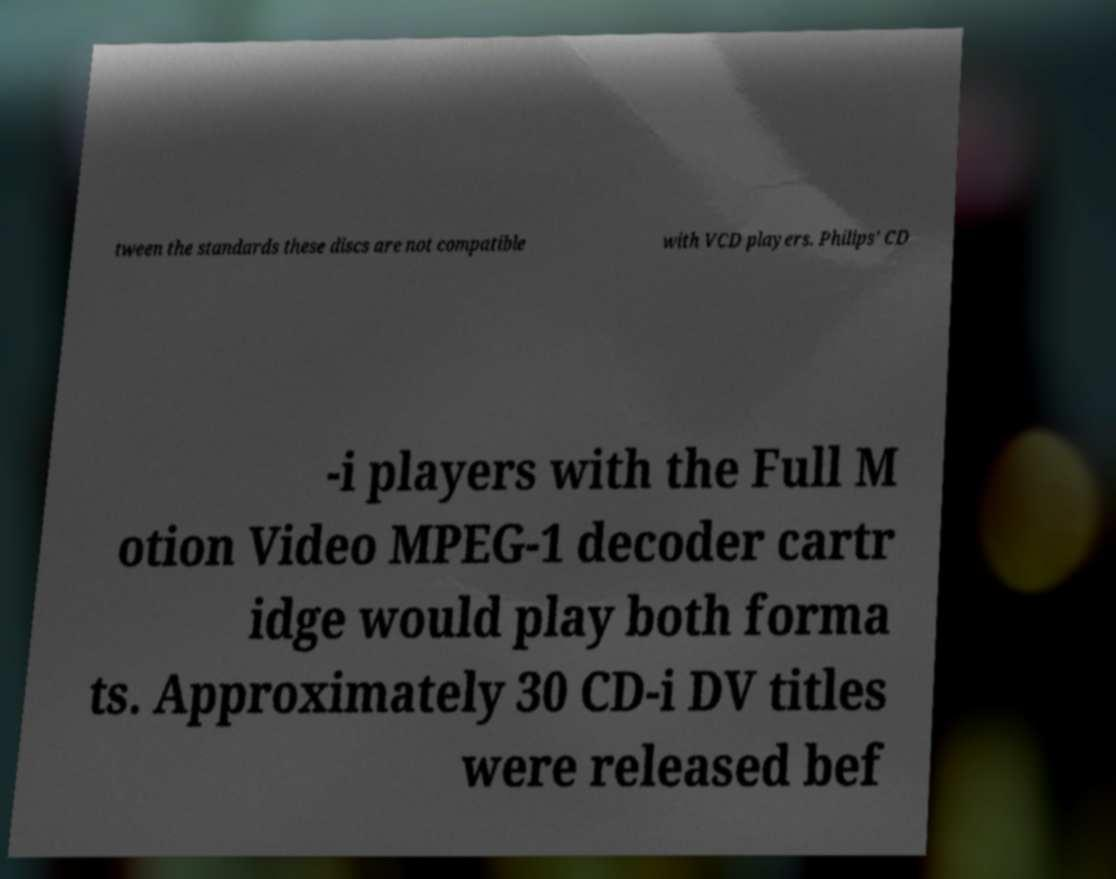Could you extract and type out the text from this image? tween the standards these discs are not compatible with VCD players. Philips' CD -i players with the Full M otion Video MPEG-1 decoder cartr idge would play both forma ts. Approximately 30 CD-i DV titles were released bef 